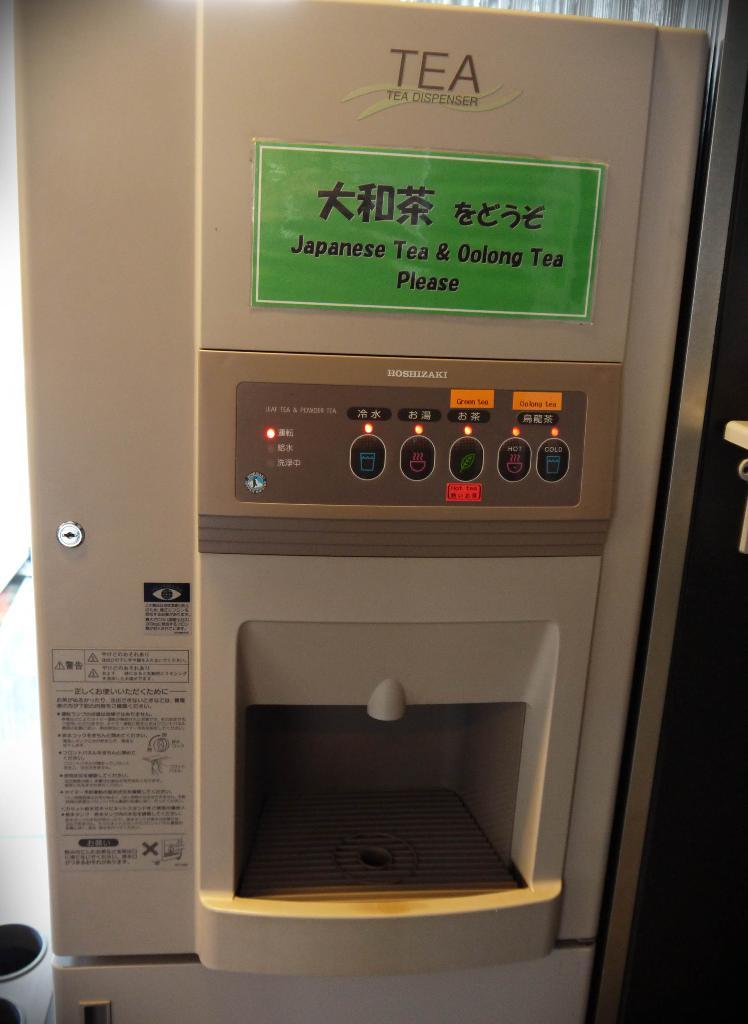<image>
Give a short and clear explanation of the subsequent image. a Japanese tea dispenser that has varieties of hot and cold tea 